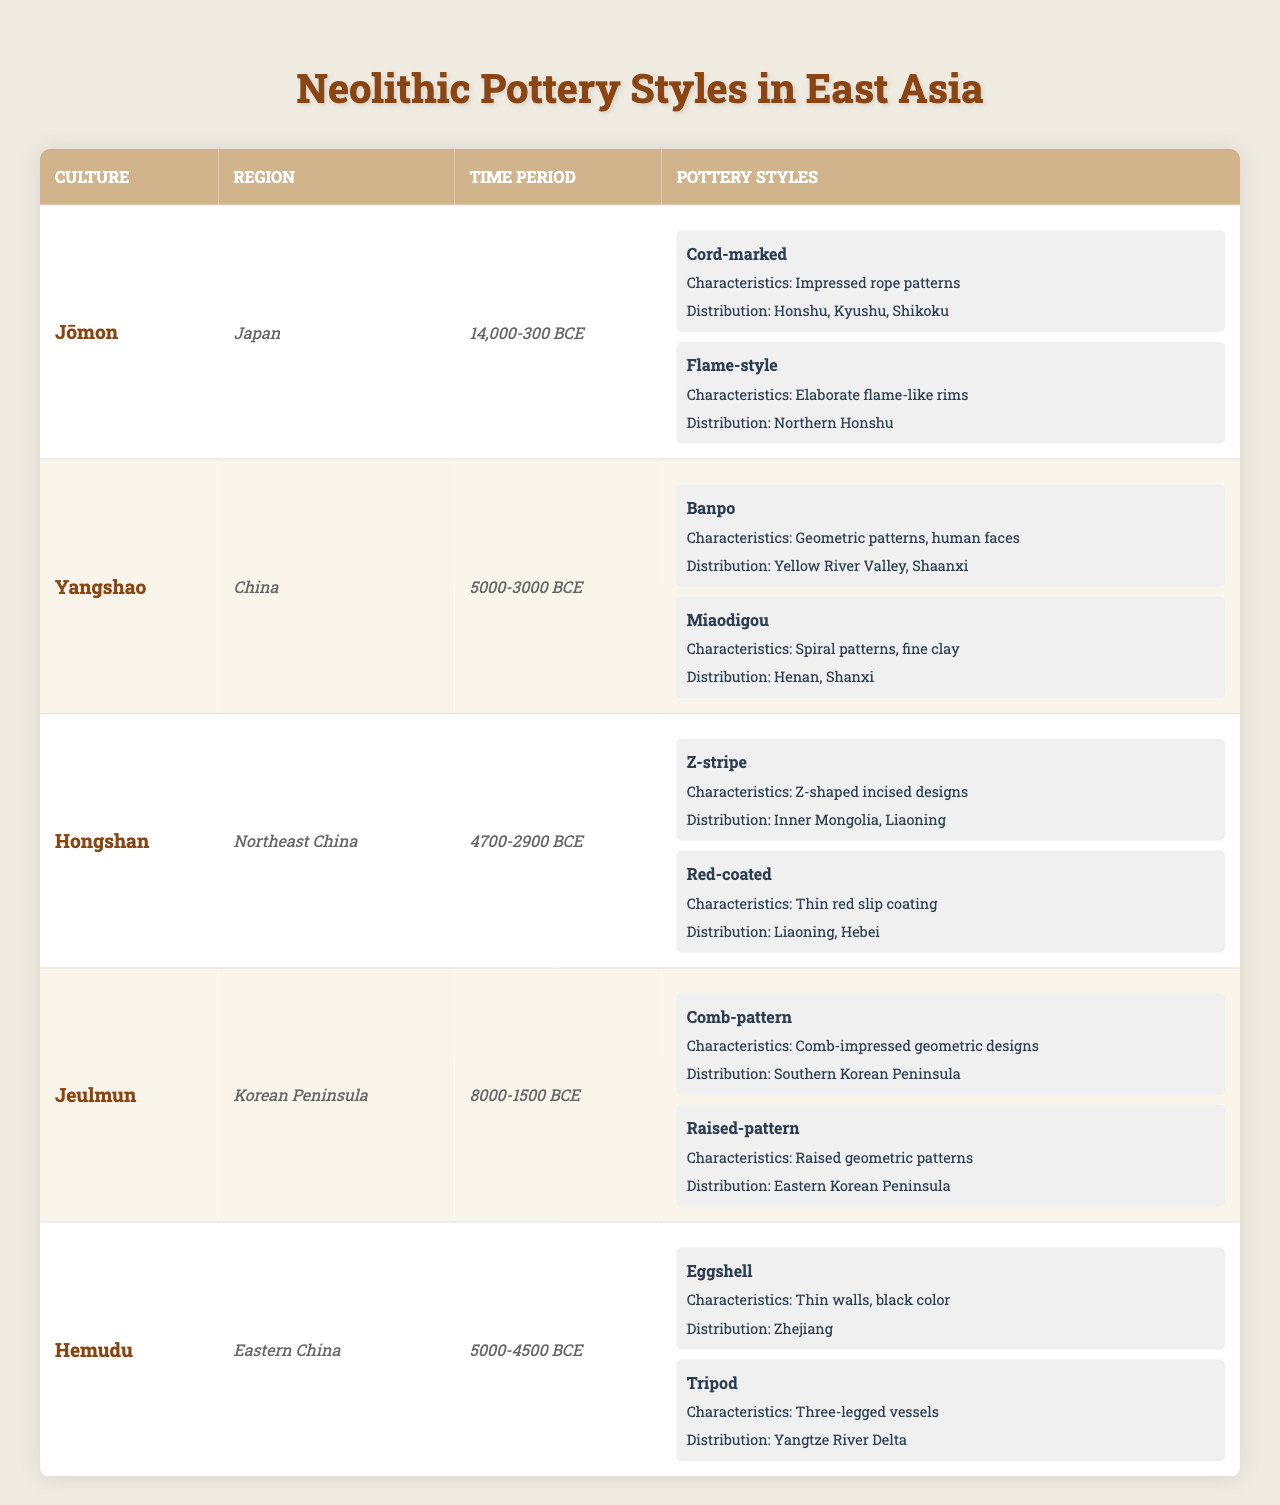What are the different pottery styles associated with the Yangshao culture? The table lists the pottery styles for each culture, and the Yangshao culture has two styles mentioned: Banpo and Miaodigou.
Answer: Banpo and Miaodigou Which region in Japan is known for the Flame-style pottery? The table specifies the distribution of the Flame-style pottery, which is limited to Northern Honshu in Japan.
Answer: Northern Honshu How many pottery styles are present in the Jeulmun culture? By reviewing the entries under the Jeulmun culture, there are two listed pottery styles: Comb-pattern and Raised-pattern.
Answer: 2 Is there a pottery style with characteristics of raised geometric patterns? According to the table, the Raised-pattern is listed under the Jeulmun culture, confirming the presence of such a style.
Answer: Yes Which culture has a pottery style characterized by thin walls and a black color? The table shows that the Hemudu culture has the Eggshell pottery style, which is described as having thin walls and a black color.
Answer: Hemudu What is the time period during which the Hongshan culture existed? The time period for the Hongshan culture is explicitly stated in the table as 4700-2900 BCE.
Answer: 4700-2900 BCE How many regions are associated with the distribution of the Cord-marked pottery style? The table shows that the Cord-marked style associated with the Jōmon culture is distributed across three regions: Honshu, Kyushu, and Shikoku.
Answer: 3 Which culture has the most diverse distribution of pottery styles? By analyzing the distributions in the table, the Yangshao culture has pottery styles distributed across two distinct regions: Yellow River Valley and Shaanxi for Banpo, and Henan and Shanxi for Miaodigou. Therefore, it shows diversity as compared to others with fewer regions.
Answer: Yangshao What can be inferred about the geographic spread of the Red-coated pottery style? The distribution of the Red-coated style under the Hongshan culture indicates that it exists in two regions: Liaoning and Hebei, suggesting a somewhat limited spread compared to styles found in three regions.
Answer: Limited spread in Liaoning and Hebei Are there any pottery styles that have characteristics involving incised designs? The table identifies the Z-stripe style under the Hongshan culture, which includes Z-shaped incised designs. Thus, there is at least one style with these characteristics.
Answer: Yes What is the significance of the distribution of pottery styles in understanding cultural interactions? Analyzing the distribution can reveal trade routes, cultural exchanges, or migration patterns by seeing which styles are present in overlapping regions. Styles like the Cord-marked have broader regions, indicating wider interaction.
Answer: Reveals cultural interactions through trade or migration 